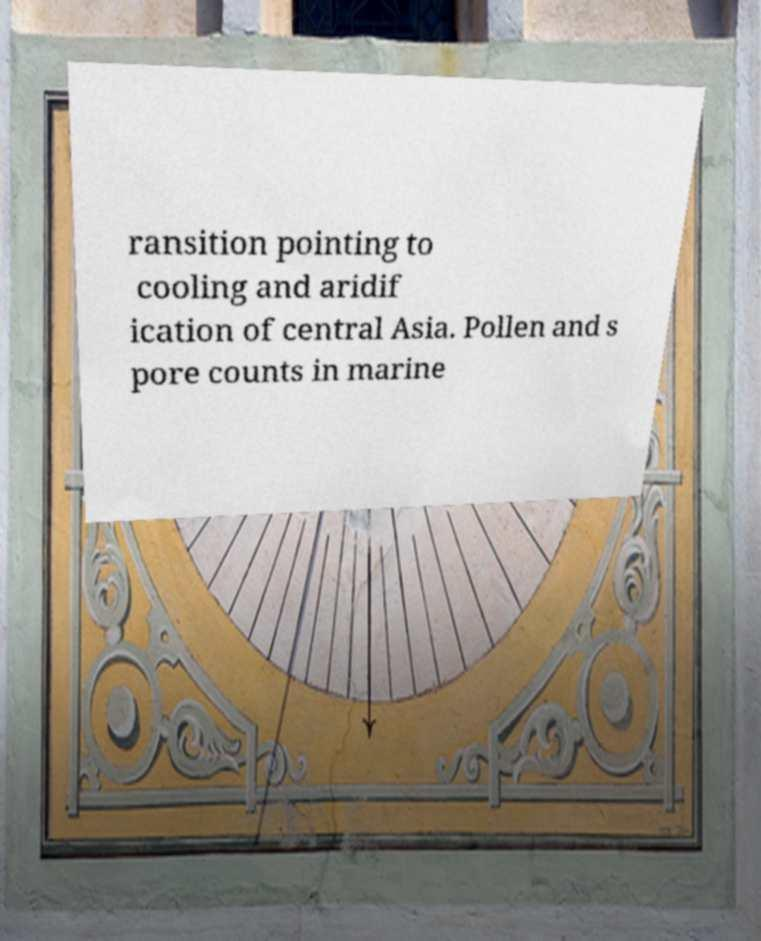Please read and relay the text visible in this image. What does it say? ransition pointing to cooling and aridif ication of central Asia. Pollen and s pore counts in marine 